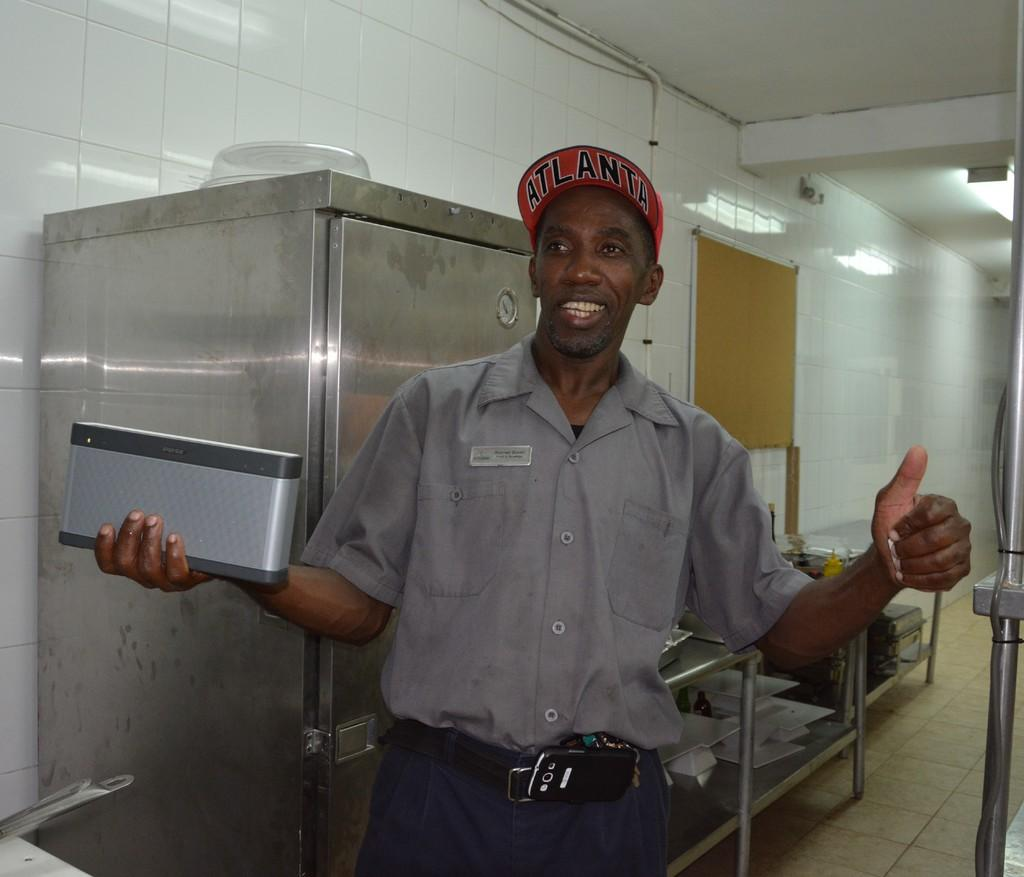<image>
Create a compact narrative representing the image presented. Maintenance worker wearing a red baseball cap with Atlanta in black letters holding a rectangular object. 